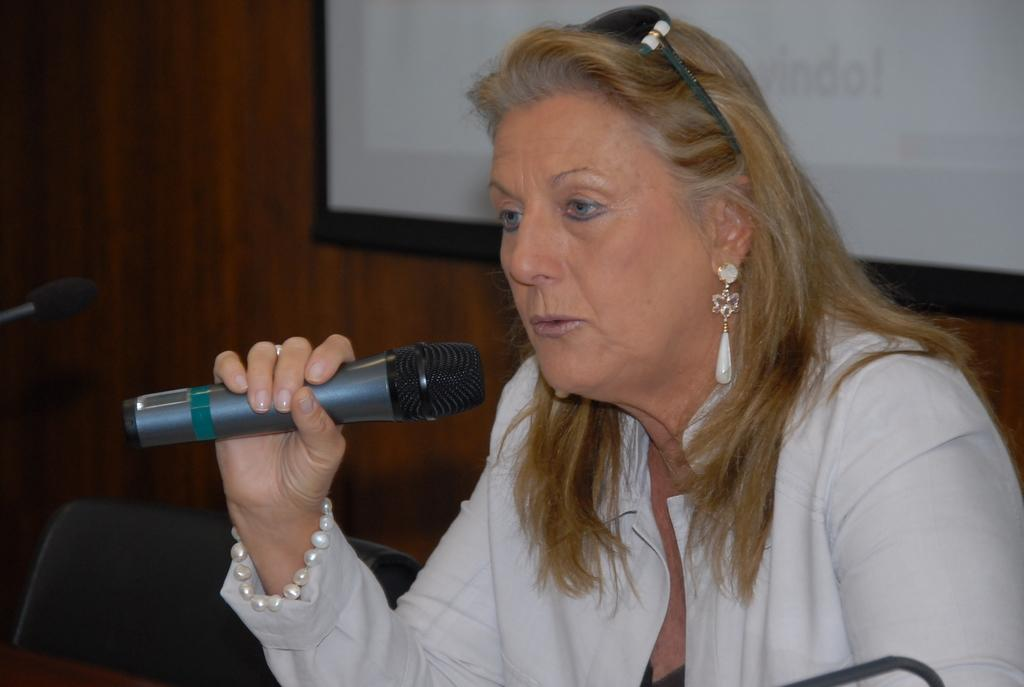Who is the main subject in the image? There is a woman in the image. What is the woman wearing? The woman is wearing a white dress and a pearl bracelet. What is the woman holding in the image? The woman is holding a microphone. What is the woman doing in the image? The woman is talking. What can be seen in the background of the image? There is a screen in the background of the image. What piece of furniture is located beside the woman? There is a chair beside the woman. Is there any sleet visible in the image? There is no mention of sleet in the provided facts, and therefore it cannot be determined if sleet is present in the image. 